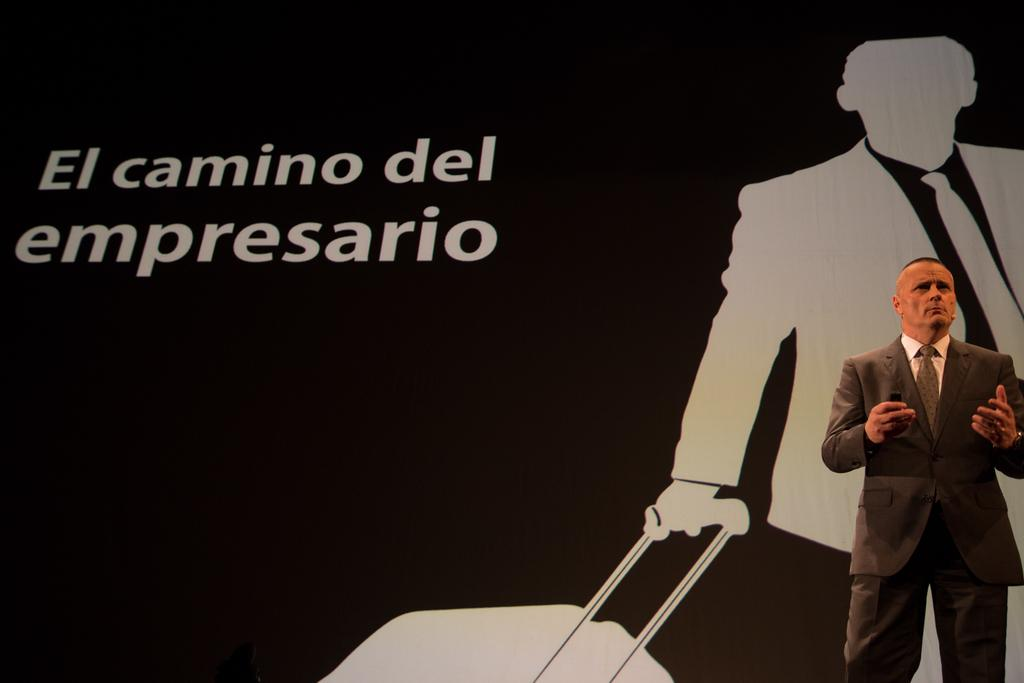Who is present in the image? There is a man in the image. What is the man wearing? The man is wearing a suit. What is the man doing in the image? The man is talking. What can be seen in the background of the image? There is a screen or banner in the background of the image. What is written or displayed on the screen or banner? There is text on the screen or banner. How many babies are holding hands in the image? There are no babies present in the image, and therefore no hands or holding can be observed. 